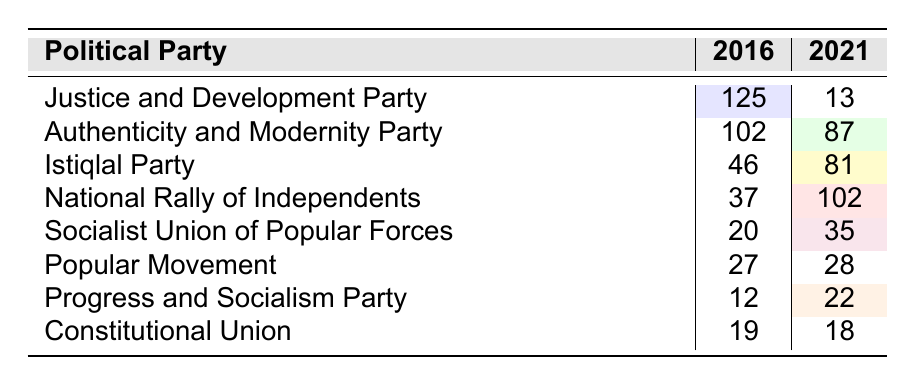What was the total number of seats held by the Justice and Development Party in 2016? The table shows that the Justice and Development Party had 125 seats in 2016.
Answer: 125 How many seats did the National Rally of Independents gain from 2016 to 2021? In 2016, the National Rally of Independents had 37 seats and in 2021, they had 102 seats. To find the gain, subtract 37 from 102, which equals 65.
Answer: 65 Which party saw the largest decrease in seats from 2016 to 2021? By comparing the seat counts: Justice and Development Party lost 112 seats (125 - 13), Authenticity and Modernity Party lost 15 (102 - 87), Istiqlal Party gained 35 (46 - 81), and others similarly. The Justice and Development Party had the largest decrease.
Answer: Justice and Development Party What is the total number of seats held by all parties in 2021? To find this, we need to sum up the seats for all parties in 2021: 13 + 87 + 81 + 102 + 35 + 28 + 22 + 18 = 386.
Answer: 386 Did the Popular Movement gain or lose seats from 2016 to 2021? The Popular Movement held 27 seats in 2016 and 28 in 2021, indicating it gained 1 seat which is an increase.
Answer: Gained What is the average number of seats for the Istiqlal Party and the Socialist Union of Popular Forces across the two years? Istiqlal had 46 seats in 2016 and 81 in 2021, summing to 127. Socialist Union had 20 in 2016 and 35 in 2021, summing to 55. The average is (127 + 55) / 4 = 45.5.
Answer: 45.5 How many parties experienced an increase in the number of seats from 2016 to 2021? Only the Istiqlal Party and the National Rally of Independents saw increases in their count, as all others either lost seats or remained the same.
Answer: 2 If the Constitutional Union lost seats, how many did they lose? The Constitutional Union had 19 seats in 2016 and 18 in 2021, which means they lost 1 seat by subtracting 18 from 19.
Answer: 1 What percentage of seats did the Justice and Development Party hold in total in 2016? The total number of seats among all parties in 2016 is 125 + 102 + 46 + 37 + 20 + 27 + 12 + 19 = 388. The portion held by the Justice and Development Party is (125/388) * 100 = approximately 32.2%.
Answer: 32.2% Which party had the highest number of seats in 2021? The National Rally of Independents had 102 seats in 2021, which is the highest compared to other parties for that year.
Answer: National Rally of Independents 